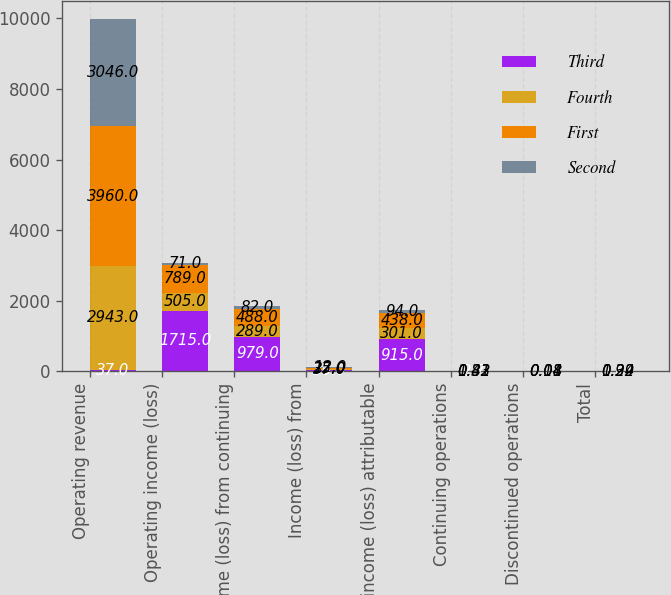Convert chart. <chart><loc_0><loc_0><loc_500><loc_500><stacked_bar_chart><ecel><fcel>Operating revenue<fcel>Operating income (loss)<fcel>Income (loss) from continuing<fcel>Income (loss) from<fcel>Net income (loss) attributable<fcel>Continuing operations<fcel>Discontinued operations<fcel>Total<nl><fcel>Third<fcel>37<fcel>1715<fcel>979<fcel>36<fcel>915<fcel>2.7<fcel>0.11<fcel>2.81<nl><fcel>Fourth<fcel>2943<fcel>505<fcel>289<fcel>37<fcel>301<fcel>0.81<fcel>0.11<fcel>0.92<nl><fcel>First<fcel>3960<fcel>789<fcel>488<fcel>25<fcel>438<fcel>1.42<fcel>0.08<fcel>1.34<nl><fcel>Second<fcel>3046<fcel>71<fcel>82<fcel>12<fcel>94<fcel>0.33<fcel>0.04<fcel>0.29<nl></chart> 